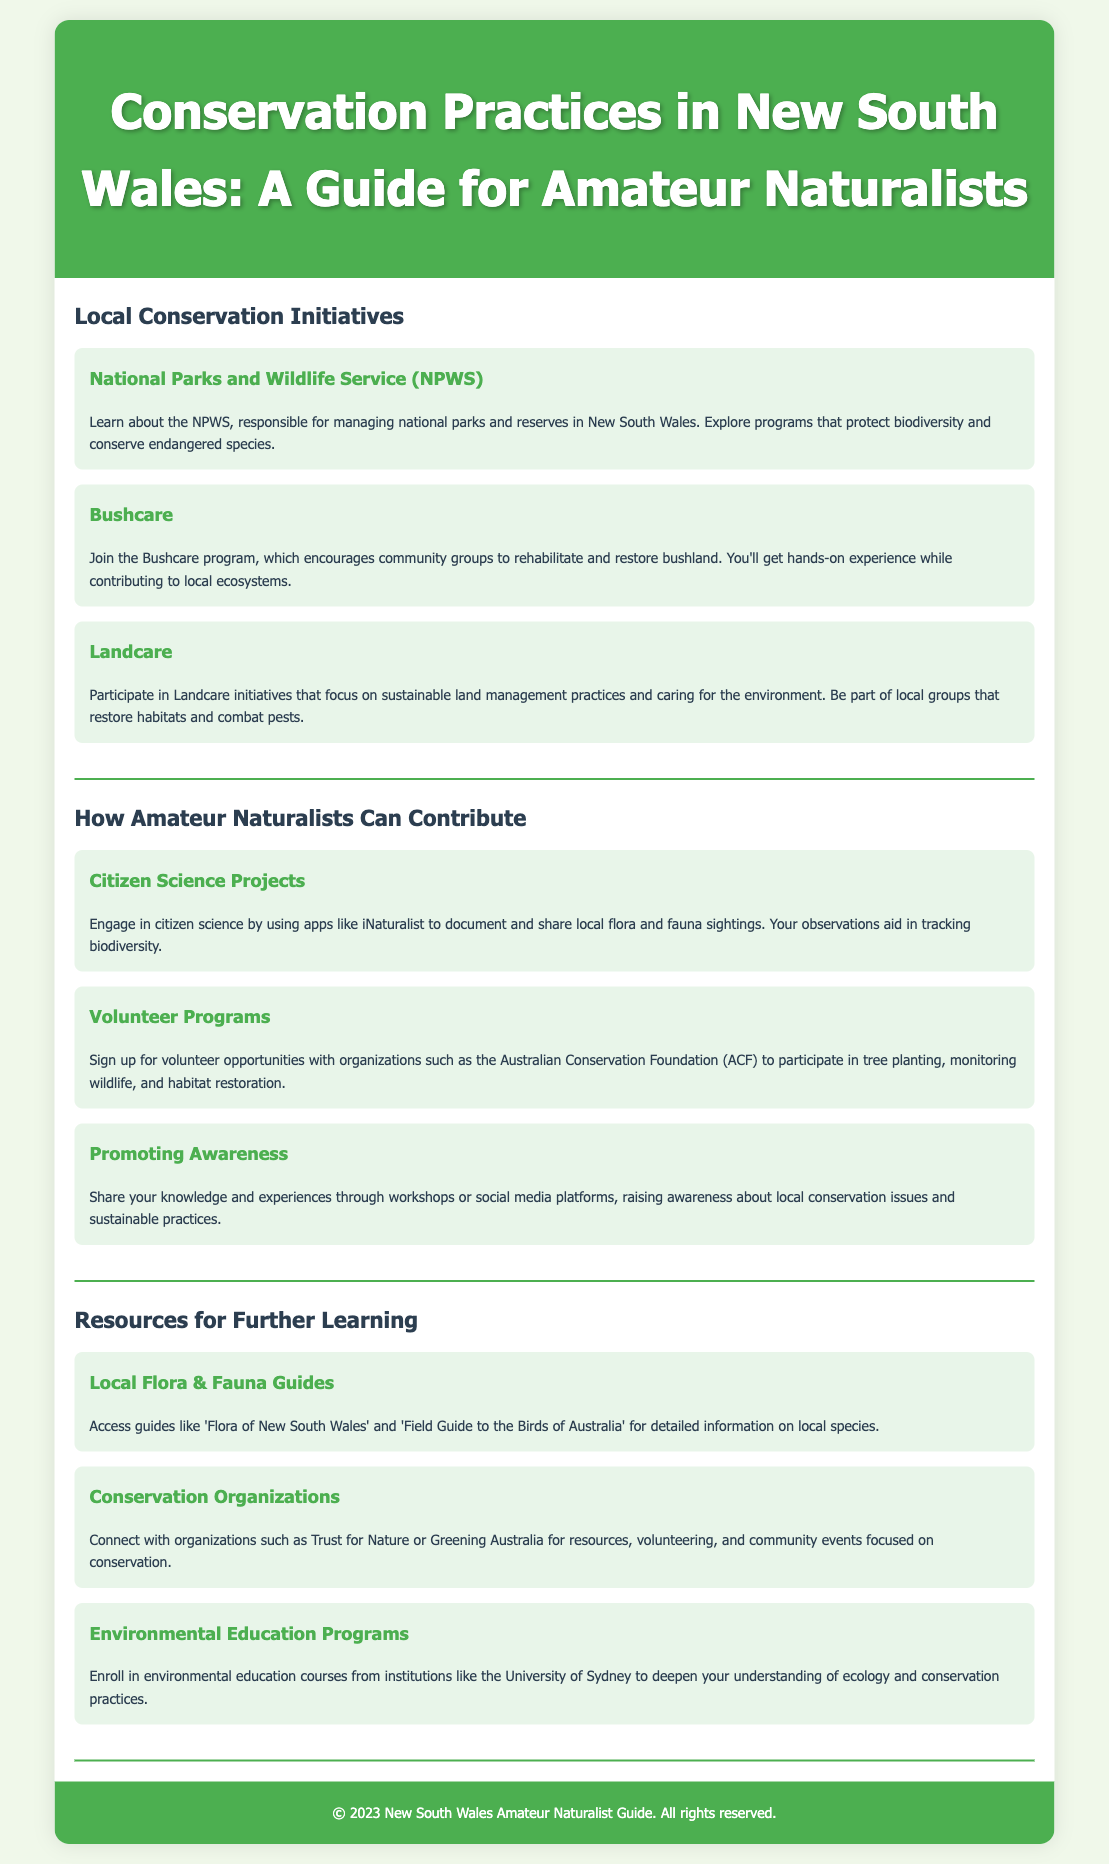What is the primary organization responsible for managing national parks in NSW? The document states that the NPWS is responsible for managing national parks and reserves in New South Wales.
Answer: NPWS What program encourages community groups to rehabilitate bushland? The document describes the Bushcare program, which encourages community groups to rehabilitate and restore bushland.
Answer: Bushcare What initiative focuses on sustainable land management practices? The Landcare initiative is mentioned as focusing on sustainable land management practices and caring for the environment.
Answer: Landcare What citizen science app is recommended for documenting flora and fauna? The document suggests using the iNaturalist app for documenting and sharing local flora and fauna sightings.
Answer: iNaturalist Which organization provides volunteer opportunities for tree planting? The Australian Conservation Foundation (ACF) is mentioned as an organization where you can sign up for volunteer opportunities, including tree planting.
Answer: Australian Conservation Foundation What type of programs can you enroll in at the University of Sydney? The document refers to environmental education courses offered by the University of Sydney for a deeper understanding of ecology and conservation practices.
Answer: Environmental education courses How can amateur naturalists promote local conservation awareness? Sharing knowledge and experiences through workshops or social media platforms is suggested as a way to promote local conservation awareness.
Answer: Workshops or social media What is one resource for learning about local species? The document lists guides like 'Flora of New South Wales' as a resource for learning about local species.
Answer: 'Flora of New South Wales' What color is used for the header background in the rendered document? The header background color is detailed in the style section as a shade of green, specifically #4CAF50.
Answer: Green 